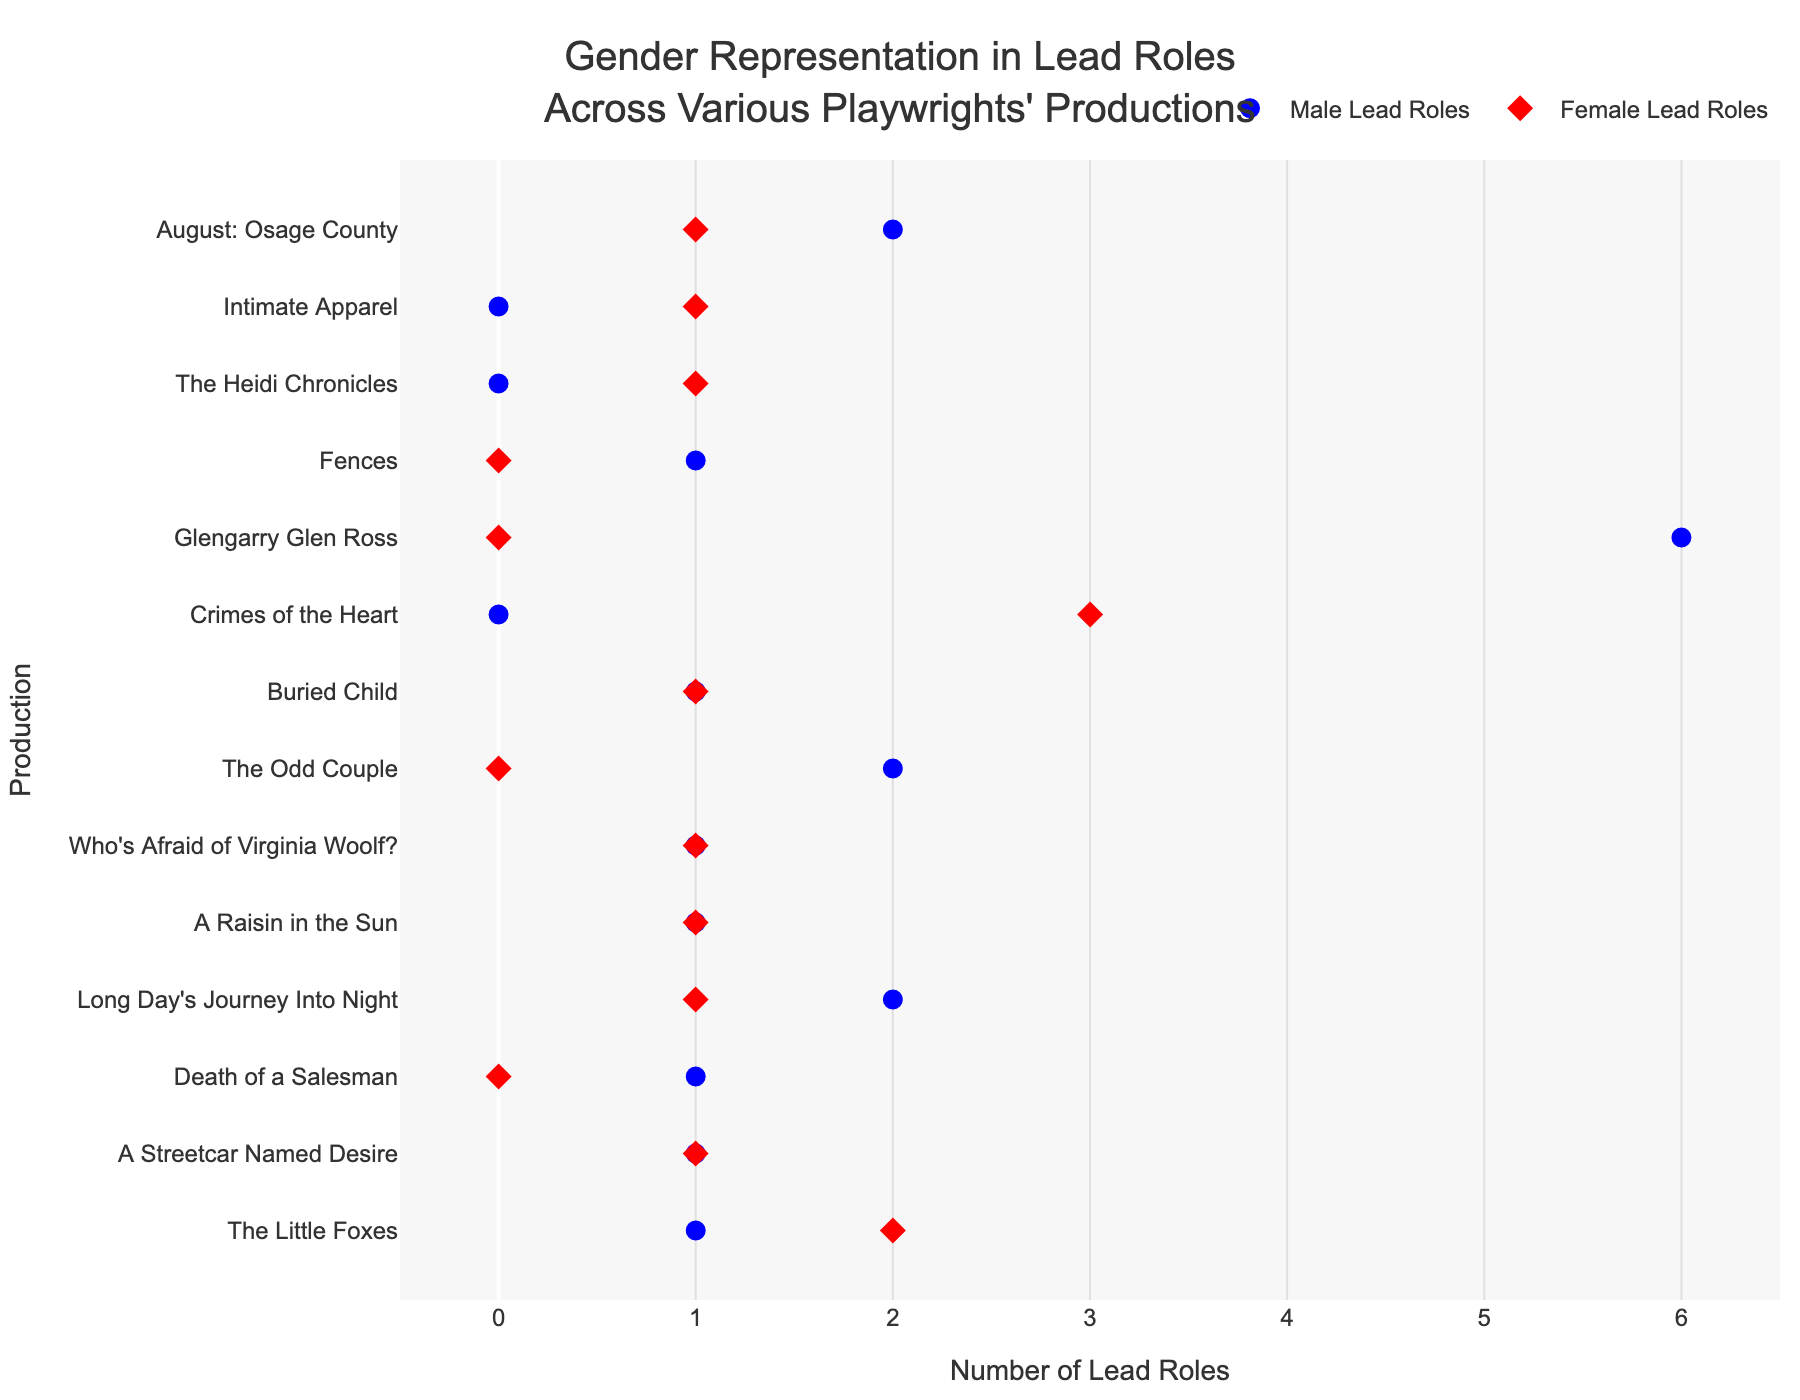Which production had the highest number of male lead roles? To find the production with the highest number of male lead roles, look for the marker on the x-axis with the highest value for male leads, indicated by blue circles. "Glengarry Glen Ross" by David Mamet has the highest male lead roles with a count of 6.
Answer: Glengarry Glen Ross Which playwright had a female lead role in 2003? Identify the year 2003, then note the production for that year and its playwright. For 2003, "Intimate Apparel" by Lynn Nottage had a female lead role, as shown by a red diamond marker.
Answer: Lynn Nottage How many productions have an equal number of male and female lead roles? Look for instances where the blue and red markers are aligned vertically for a production, indicating equal male and female lead roles. There are three such productions: "A Streetcar Named Desire", "A Raisin in the Sun", and "Buried Child".
Answer: 3 What is the production with the earliest year and how many female lead roles does it have? Identify the earliest year in the female lead role markers, which is 1939, and find the corresponding production and count of female lead roles. "The Little Foxes" has 2 female lead roles in 1939.
Answer: The Little Foxes, 2 Which production has no male lead roles but the highest number of female lead roles? Find the production with a blue marker at 0 and the highest red marker value, indicating no male lead roles and the highest female lead roles. "Crimes of the Heart" by Beth Henley has 0 male lead roles and the highest number of female lead roles, which is 3.
Answer: Crimes of the Heart How many male lead roles are there in "Who's Afraid of Virginia Woolf?"? Locate the production "Who's Afraid of Virginia Woolf?" and look for the blue circle indicating the count of male lead roles. There is 1 male lead role.
Answer: 1 Compare the number of male lead roles in "The Odd Couple" to that in "August: Osage County". Which production has more male lead roles? Find "The Odd Couple" and "August: Osage County" on the y-axis, then compare their blue circle markers. "The Odd Couple" has 2 male lead roles, while "August: Osage County" also has 2 male lead roles, so they have the same number.
Answer: Same What is the total number of female lead roles across all productions? Sum the number of female lead roles by looking at all the red markers on the x-axis. Summing up gives: 0+1+1+1+2+0+3+1+1+1+1=12.
Answer: 12 Which production has the widest discrepancy between male and female lead roles? Find the production with the largest difference on the x-axis between blue and red markers. "Glengarry Glen Ross" has 6 male lead roles and 0 female lead roles, giving a discrepancy of 6.
Answer: Glengarry Glen Ross 